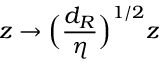Convert formula to latex. <formula><loc_0><loc_0><loc_500><loc_500>z \rightarrow \left ( \frac { d _ { R } } { \eta } \right ) ^ { 1 / 2 } z</formula> 